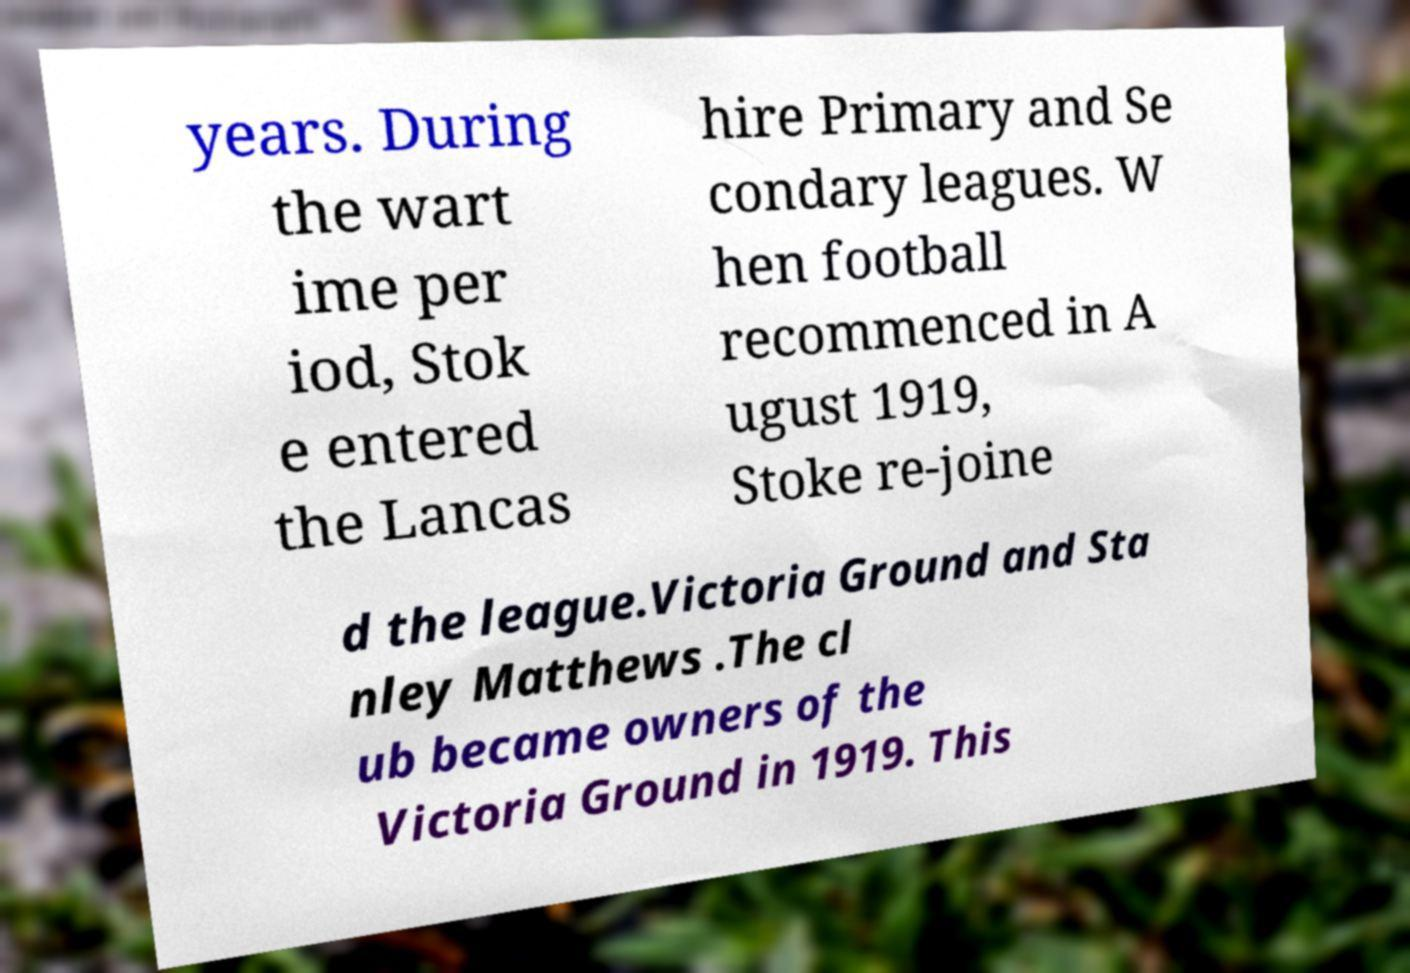For documentation purposes, I need the text within this image transcribed. Could you provide that? years. During the wart ime per iod, Stok e entered the Lancas hire Primary and Se condary leagues. W hen football recommenced in A ugust 1919, Stoke re-joine d the league.Victoria Ground and Sta nley Matthews .The cl ub became owners of the Victoria Ground in 1919. This 